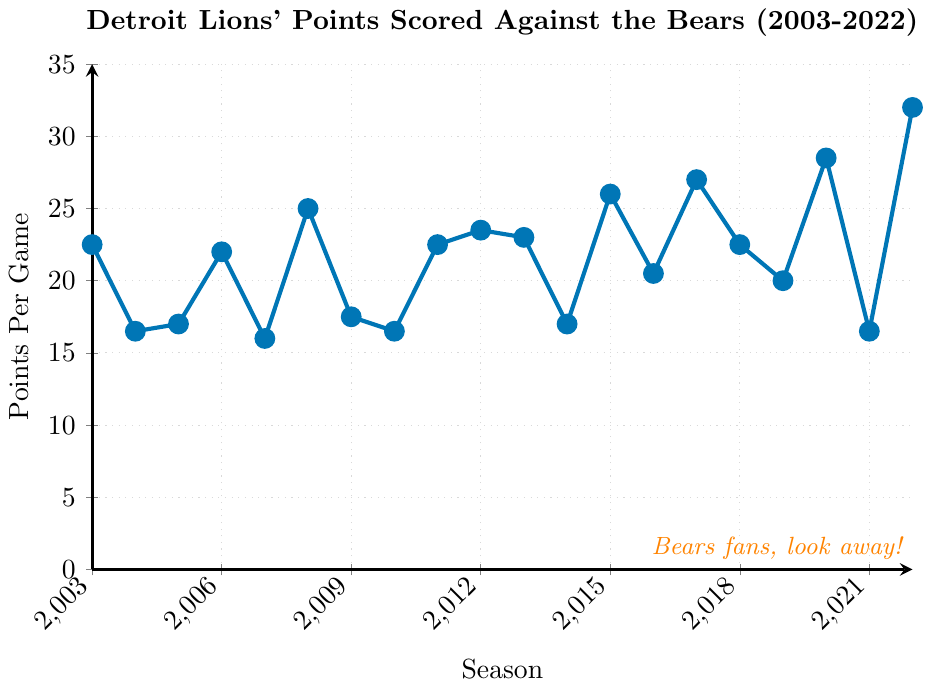What was the Detroit Lions' highest points per game against the Bears over the last 20 seasons? Look at the plot to find the highest point on the line chart. The highest value is at the year 2022, where the Lions scored 32.0 points per game.
Answer: 32.0 What is the difference in points per game between the 2008 and 2022 seasons? Find the points per game for the 2008 season (25.0) and for the 2022 season (32.0). Then, subtract the 2008 value from the 2022 value: 32.0 - 25.0 = 7.0.
Answer: 7.0 In which year did the Detroit Lions score the lowest points per game against the Bears, and what was the score? Identify the lowest point on the line chart, which occurs in the year 2007 with a value of 16.0 points per game.
Answer: 2007, 16.0 How many seasons did the Detroit Lions score more than 25 points per game against the Bears? Count the points on the line chart that are above 25.0. The relevant points are in the years 2015, 2017, 2020, and 2022. There are 4 such seasons.
Answer: 4 What was the average points per game of the Detroit Lions against the Bears from 2019 to 2022? Find the points per game values for the years 2019 to 2022: (20.0, 28.5, 16.5, 32.0). Sum these values: 20.0 + 28.5 + 16.5 + 32.0 = 97.0. Then, divide by the number of years (4): 97.0 / 4 = 24.25.
Answer: 24.25 Between 2008 and 2012, did the Detroit Lions’ points per game trend upward or downward against the Bears? Observe the trend in the line chart from 2008 (25.0), 2009 (17.5), 2010 (16.5), 2011 (22.5), and 2012 (23.5). The points initially decrease through 2010 and then increase again in 2011 and 2012. The overall trend is upward from 2010 to 2012.
Answer: Upward Compare the points per game in the years 2005 and 2016. Which year recorded higher points per game? Check the points per game for 2005 (17.0) and 2016 (20.5). The year 2016 recorded higher points per game.
Answer: 2016 What was the percentage increase in points per game from 2021 to 2022? Identify the points per game for the years 2021 (16.5) and 2022 (32.0). Calculate the percentage increase using the formula: ((32.0 - 16.5) / 16.5) * 100 = 93.94%.
Answer: 93.94% Which year had Detroit Lions' points per game closest to the average points per game over the entire 20 seasons? First, calculate the average points per game across all 20 seasons. Sum all values: 22.5 + 16.5 + 17.0 + 22.0 + 16.0 + 25.0 + 17.5 + 16.5 + 22.5 + 23.5 + 23.0 + 17.0 + 26.0 + 20.5 + 27.0 + 22.5 + 20.0 + 28.5 + 16.5 + 32.0 = 423.5. Then, divide by 20: 423.5 / 20 = 21.175. The closest value is 22.0 in 2006.
Answer: 2006 